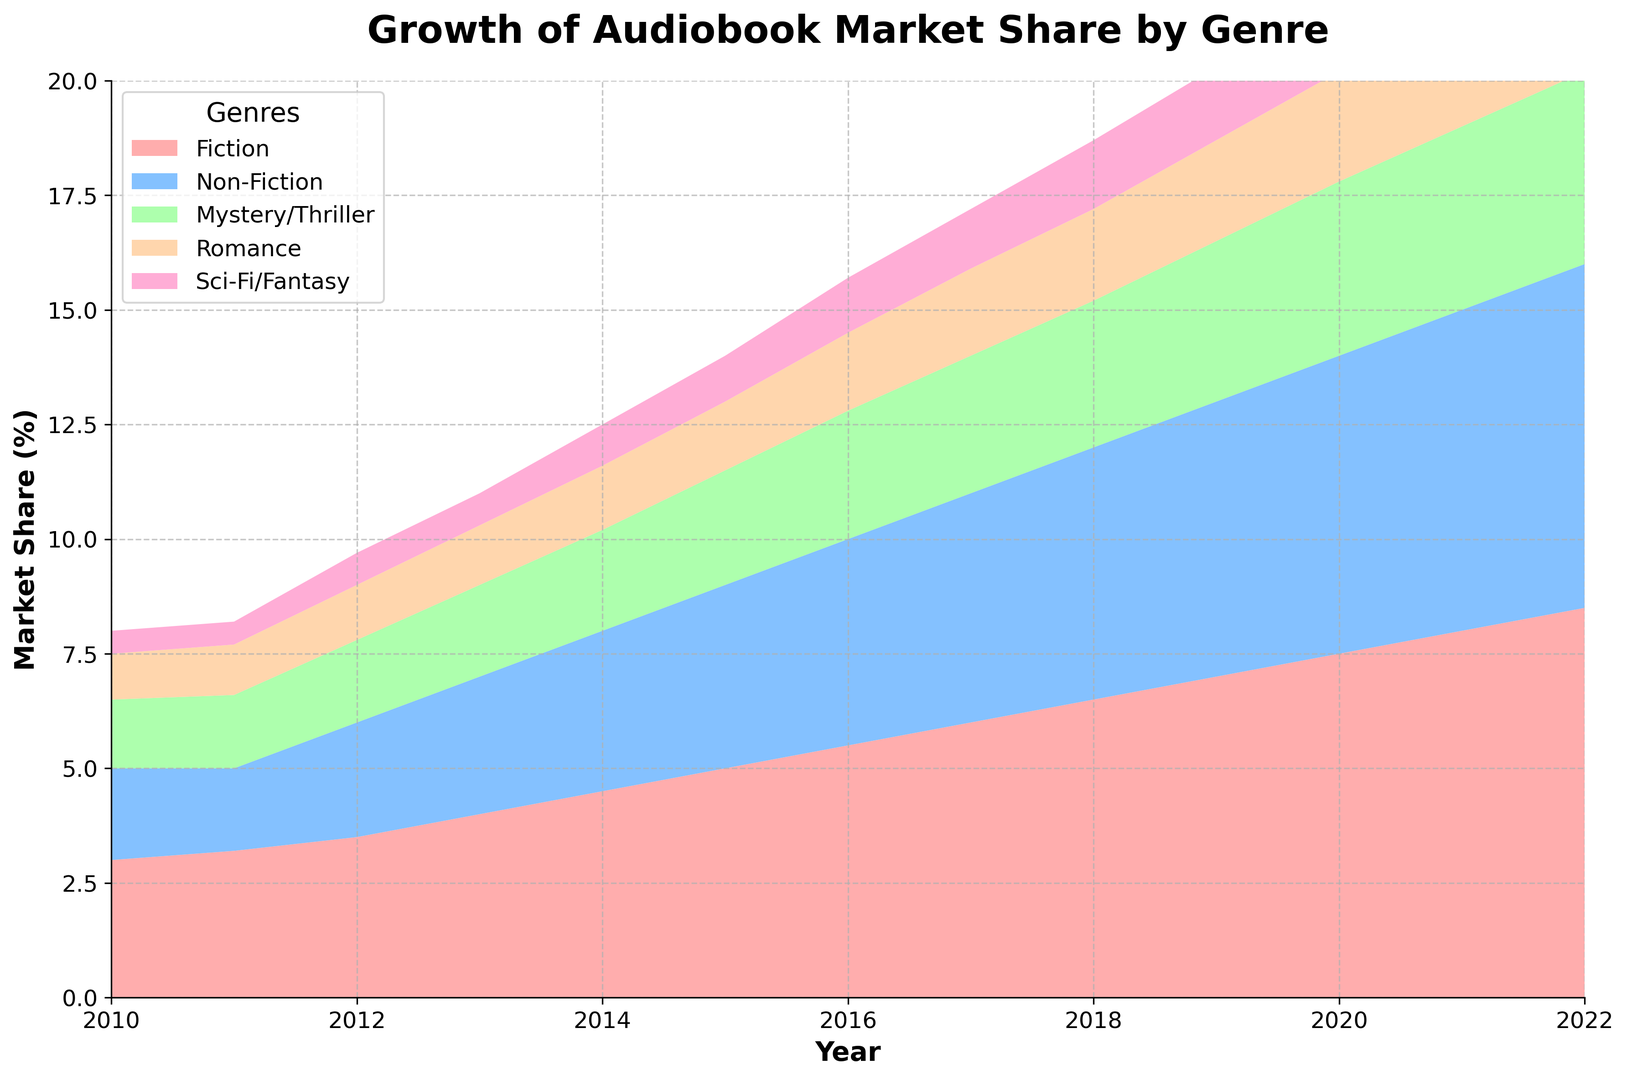Which genre had the highest market share growth in audiobooks from 2010 to 2022? By examining the plot, the genre with the largest increase in market share is Fiction, which grows from around 3% in 2010 to about 8.5% in 2022.
Answer: Fiction How much did the market share of Mystery/Thriller audiobooks grow from 2010 to 2022? In the beginning, Mystery/Thriller had a market share of 1.5% in 2010 and it increased to around 4.2% in 2022. To find the growth, subtract 1.5% from 4.2%, which results in a growth of 2.7%.
Answer: 2.7% In what year did Romance audiobooks reach a 2% market share? By looking at the Romance section of the stack plot, Romance audiobooks reached a market share of 2% by the year 2018.
Answer: 2018 Which genre has shown the least growth over the entire span from 2010 to 2022? Comparing the starting and ending percentages of all the genres, Sci-Fi/Fantasy shows the least growth, starting at 0.5% and ending at about 2.2%. This results in a total increase of 1.7%.
Answer: Sci-Fi/Fantasy Between Fiction and Non-Fiction, which genre had a higher market share in 2015? Comparing the heights of the areas for Fiction and Non-Fiction in 2015, Fiction has a market share of about 5%, while Non-Fiction is around 4%.
Answer: Fiction How much combined market share did Fiction and Non-Fiction audiobooks hold in 2022? In 2022, Fiction has a market share of about 8.5% and Non-Fiction has about 7.5%. Adding these together gives a combined market share of 16%.
Answer: 16% Which genre overtook another in market share first: Mystery/Thriller overtaking Non-Fiction, or Romance overtaking Mystery/Thriller? By referencing the plot, Mystery/Thriller overtakes Non-Fiction in around 2019, but Romance overtakes Mystery/Thriller earlier, around 2014. So, Romance overtook Mystery/Thriller first.
Answer: Romance overtaking Mystery/Thriller What is the average market share of Sci-Fi/Fantasy audiobooks over the years 2010 to 2022? To calculate the average, sum the market share values for each year from 2010 to 2022 and then divide by the number of years. The values are: 0.5, 0.5, 0.7, 0.7, 0.9, 1.0, 1.2, 1.3, 1.5, 1.6, 1.8, 2.0, 2.2. Summing these gives 15.9, and dividing by 13 years results in approximately 1.23%.
Answer: 1.23% In which year did the total market share of Fiction and Non-Fiction audiobooks exceed 10%? Looking at the individual contributions, Fiction and Non-Fiction together exceed a 10% market share starting in 2013, when Fiction is about 4% and Non-Fiction is around 3%, totaling 7% which doesn't meet the threshold. It’s in 2014 when they sum up to exceed 10%.
Answer: 2014 